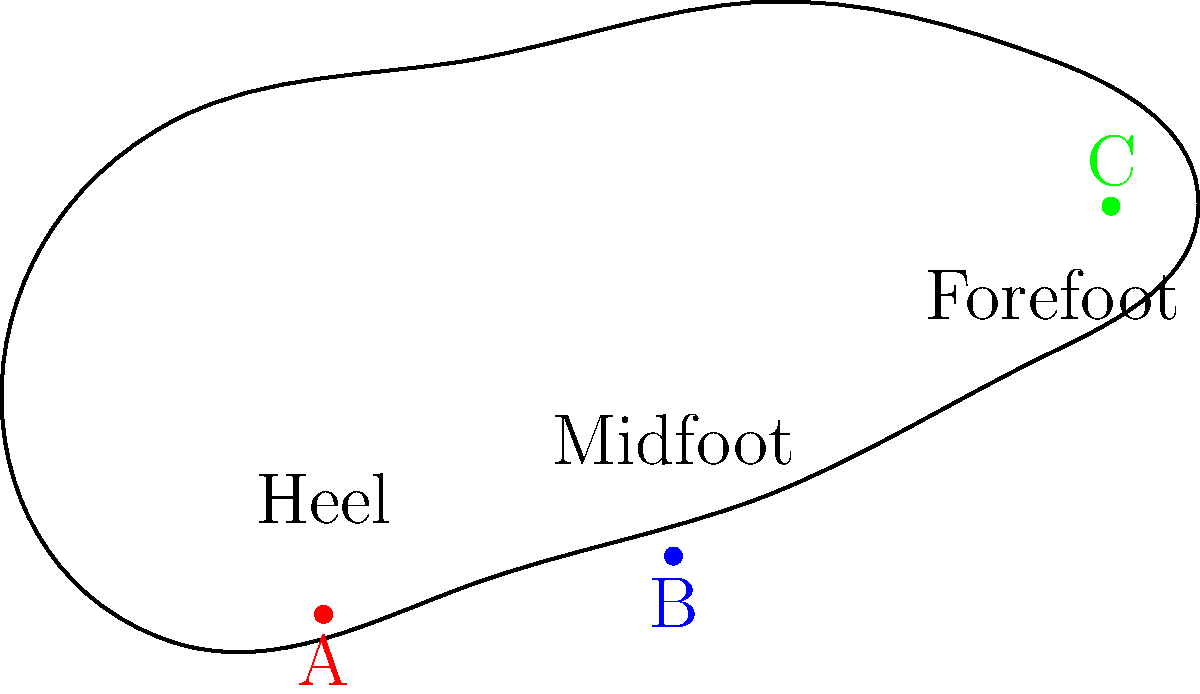During a triathlon run, which point (A, B, or C) experiences the highest pressure during the initial contact phase of the running gait cycle, and why is this important for injury prevention and performance optimization? To answer this question, let's break down the running gait cycle and analyze the pressure distribution:

1. The running gait cycle consists of stance and swing phases.
2. The stance phase can be further divided into initial contact, midstance, and toe-off.
3. During initial contact:
   a. The foot first touches the ground, typically at the heel for most runners.
   b. Point A represents the heel area.
   c. The heel experiences the highest impact forces during this phase.

4. Importance for injury prevention:
   a. High impact forces at the heel can lead to injuries such as plantar fasciitis or stress fractures.
   b. Understanding this helps in choosing appropriate footwear with adequate heel cushioning.

5. Importance for performance optimization:
   a. Efficient force distribution can improve running economy.
   b. Triathletes can work on their running technique to optimize foot strike and reduce energy loss.

6. Points B (midfoot) and C (forefoot):
   a. Experience less pressure during initial contact.
   b. Become more important during midstance and toe-off phases.

Therefore, point A experiences the highest pressure during the initial contact phase of the running gait cycle.
Answer: Point A (heel) 